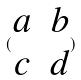Convert formula to latex. <formula><loc_0><loc_0><loc_500><loc_500>( \begin{matrix} a & b \\ c & d \end{matrix} )</formula> 